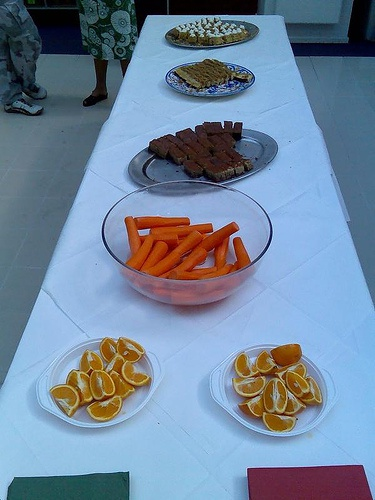Describe the objects in this image and their specific colors. I can see dining table in lightblue, darkblue, brown, and black tones, bowl in darkblue, darkgray, maroon, and brown tones, orange in darkblue, olive, tan, and maroon tones, people in darkblue, black, and blue tones, and people in darkblue, black, and teal tones in this image. 